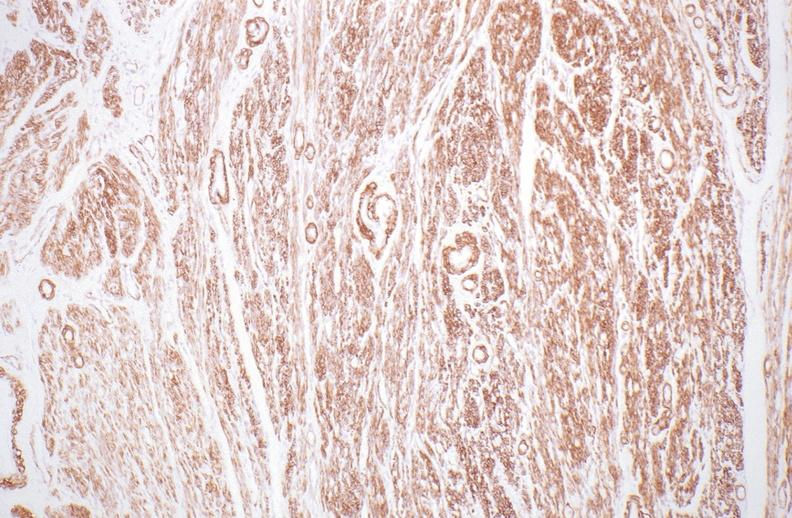what stain?
Answer the question using a single word or phrase. Normal uterus, alpha smooth muscle actin immunohistochemical 